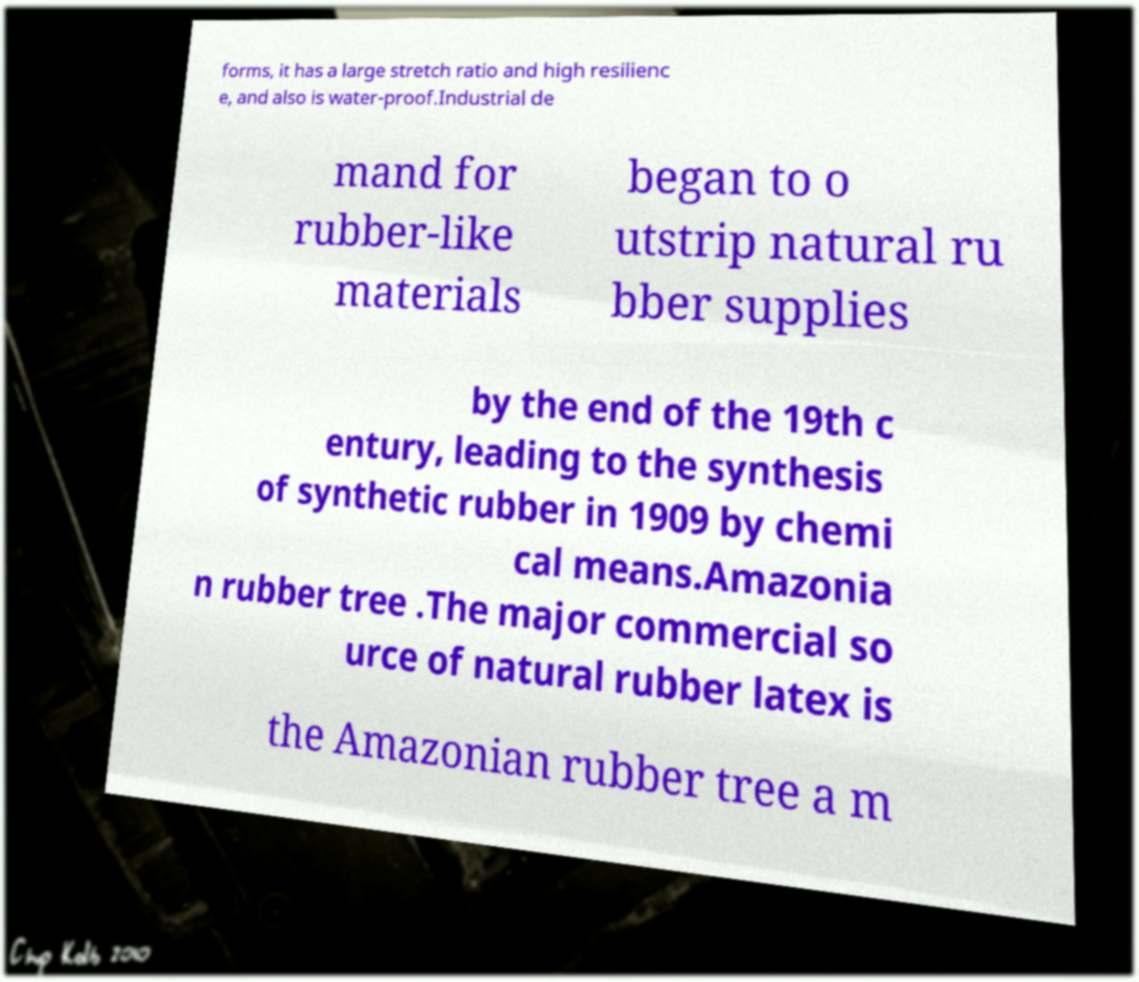For documentation purposes, I need the text within this image transcribed. Could you provide that? forms, it has a large stretch ratio and high resilienc e, and also is water-proof.Industrial de mand for rubber-like materials began to o utstrip natural ru bber supplies by the end of the 19th c entury, leading to the synthesis of synthetic rubber in 1909 by chemi cal means.Amazonia n rubber tree .The major commercial so urce of natural rubber latex is the Amazonian rubber tree a m 